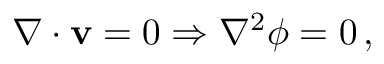Convert formula to latex. <formula><loc_0><loc_0><loc_500><loc_500>\nabla \cdot v = 0 \Rightarrow \nabla ^ { 2 } \phi = 0 \, ,</formula> 